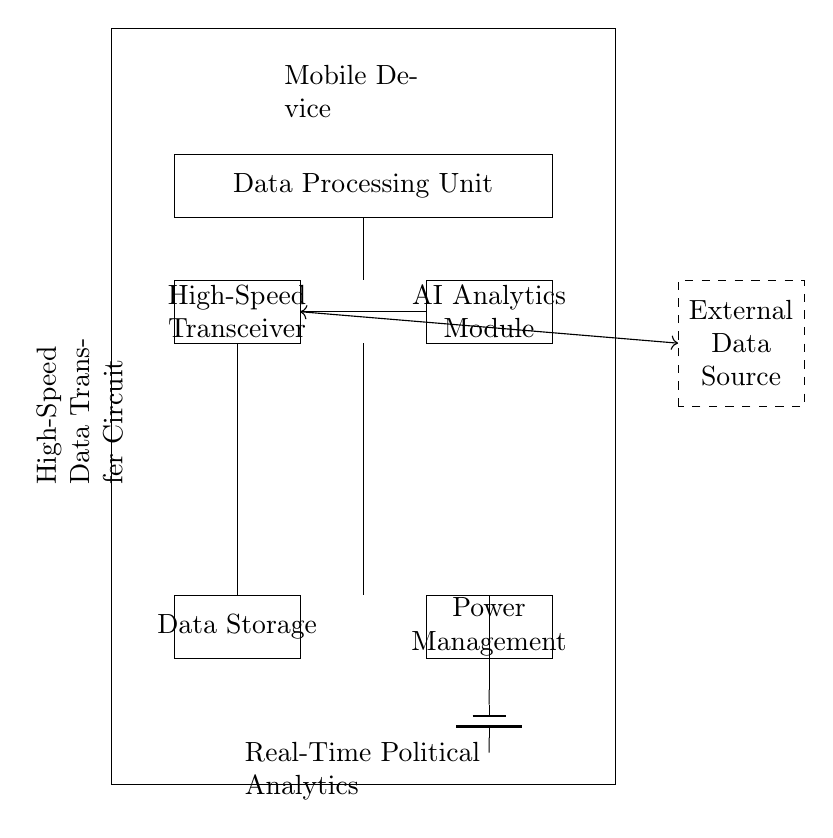What is the main component for data processing? The main component for data processing is the Data Processing Unit, which is indicated in the circuit diagram as a rectangular block labeled "Data Processing Unit."
Answer: Data Processing Unit What is the purpose of the high-speed transceiver? The high-speed transceiver is responsible for transmitting and receiving data at high speeds, which is essential for real-time political analytics as represented in the circuit diagram.
Answer: Data transmission How many main sections does the circuit have? There are five main sections in the circuit diagram: the Data Processing Unit, High-Speed Transceiver, AI Analytics Module, Data Storage, and Power Management.
Answer: Five Which unit provides power to the circuit? The Battery unit provides power to the circuit, as shown in the diagram where it is connected to the Power Management section.
Answer: Battery What does the antenna do in the circuit? The antenna facilitates wireless communication by sending and receiving signals, enabling the device to connect to external data sources, as depicted in the circuit.
Answer: Wireless communication What links the AI analytics module to data transfer? The High-Speed Transceiver links the AI Analytics Module to data transfer, as depicted by the connections shown between these components in the circuit diagram.
Answer: High-Speed Transceiver What type of data source does the circuit connect to? The circuit connects to an external data source, indicated by the dashed box labeled "External Data Source" in the diagram.
Answer: External Data Source 